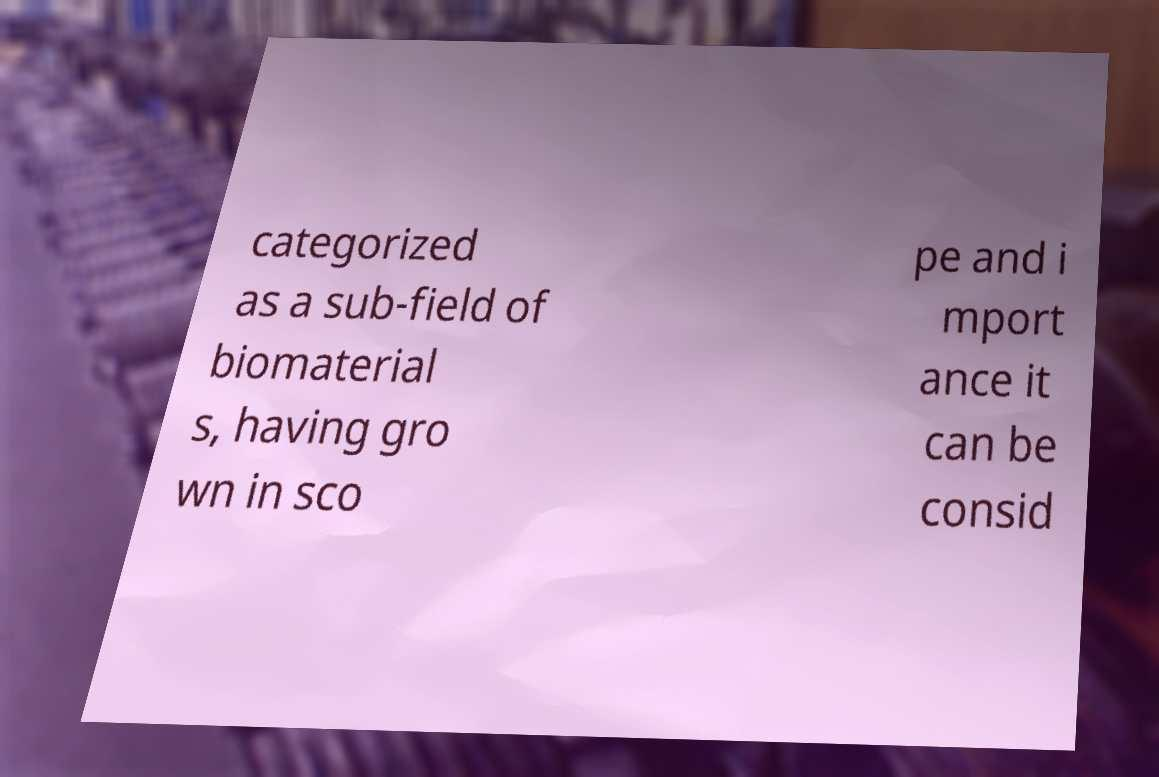I need the written content from this picture converted into text. Can you do that? categorized as a sub-field of biomaterial s, having gro wn in sco pe and i mport ance it can be consid 